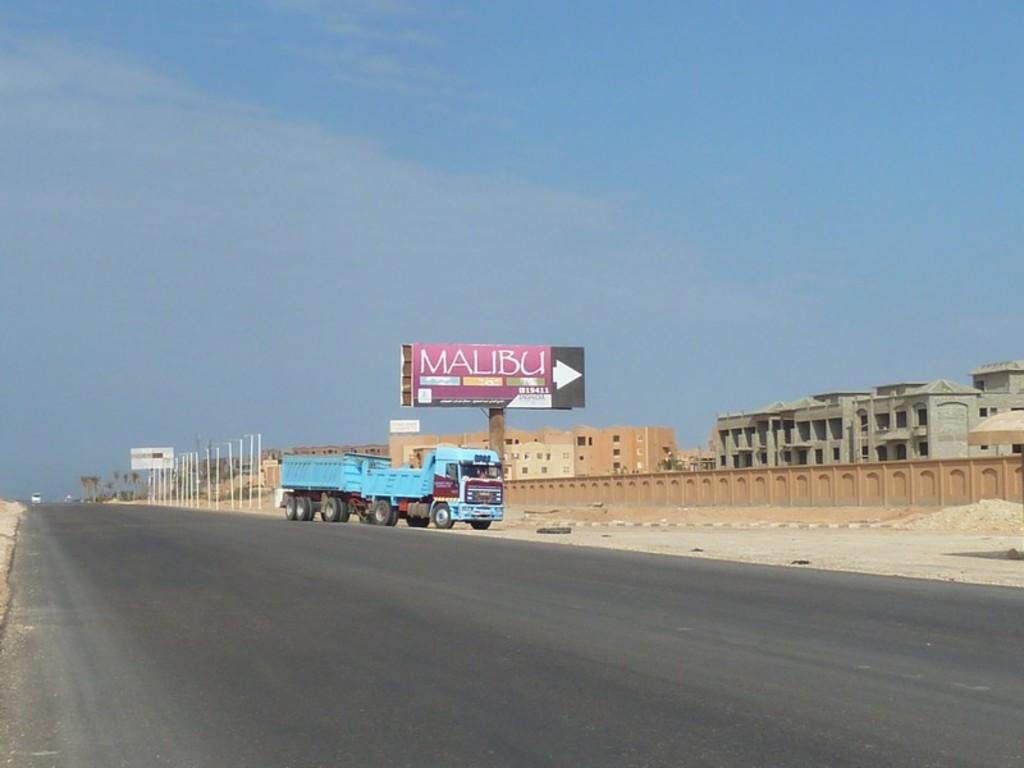<image>
Share a concise interpretation of the image provided. Blue truck is parked on the side of the road by the Malibu side 